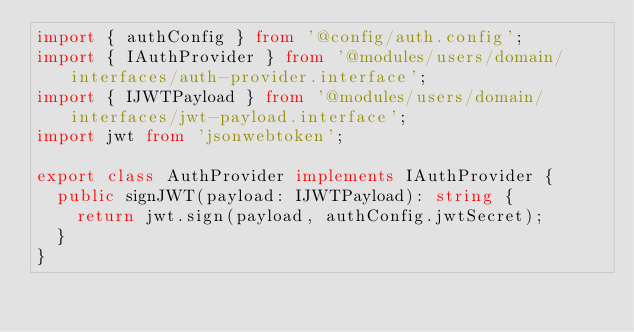<code> <loc_0><loc_0><loc_500><loc_500><_TypeScript_>import { authConfig } from '@config/auth.config';
import { IAuthProvider } from '@modules/users/domain/interfaces/auth-provider.interface';
import { IJWTPayload } from '@modules/users/domain/interfaces/jwt-payload.interface';
import jwt from 'jsonwebtoken';

export class AuthProvider implements IAuthProvider {
  public signJWT(payload: IJWTPayload): string {
    return jwt.sign(payload, authConfig.jwtSecret);
  }
}
</code> 